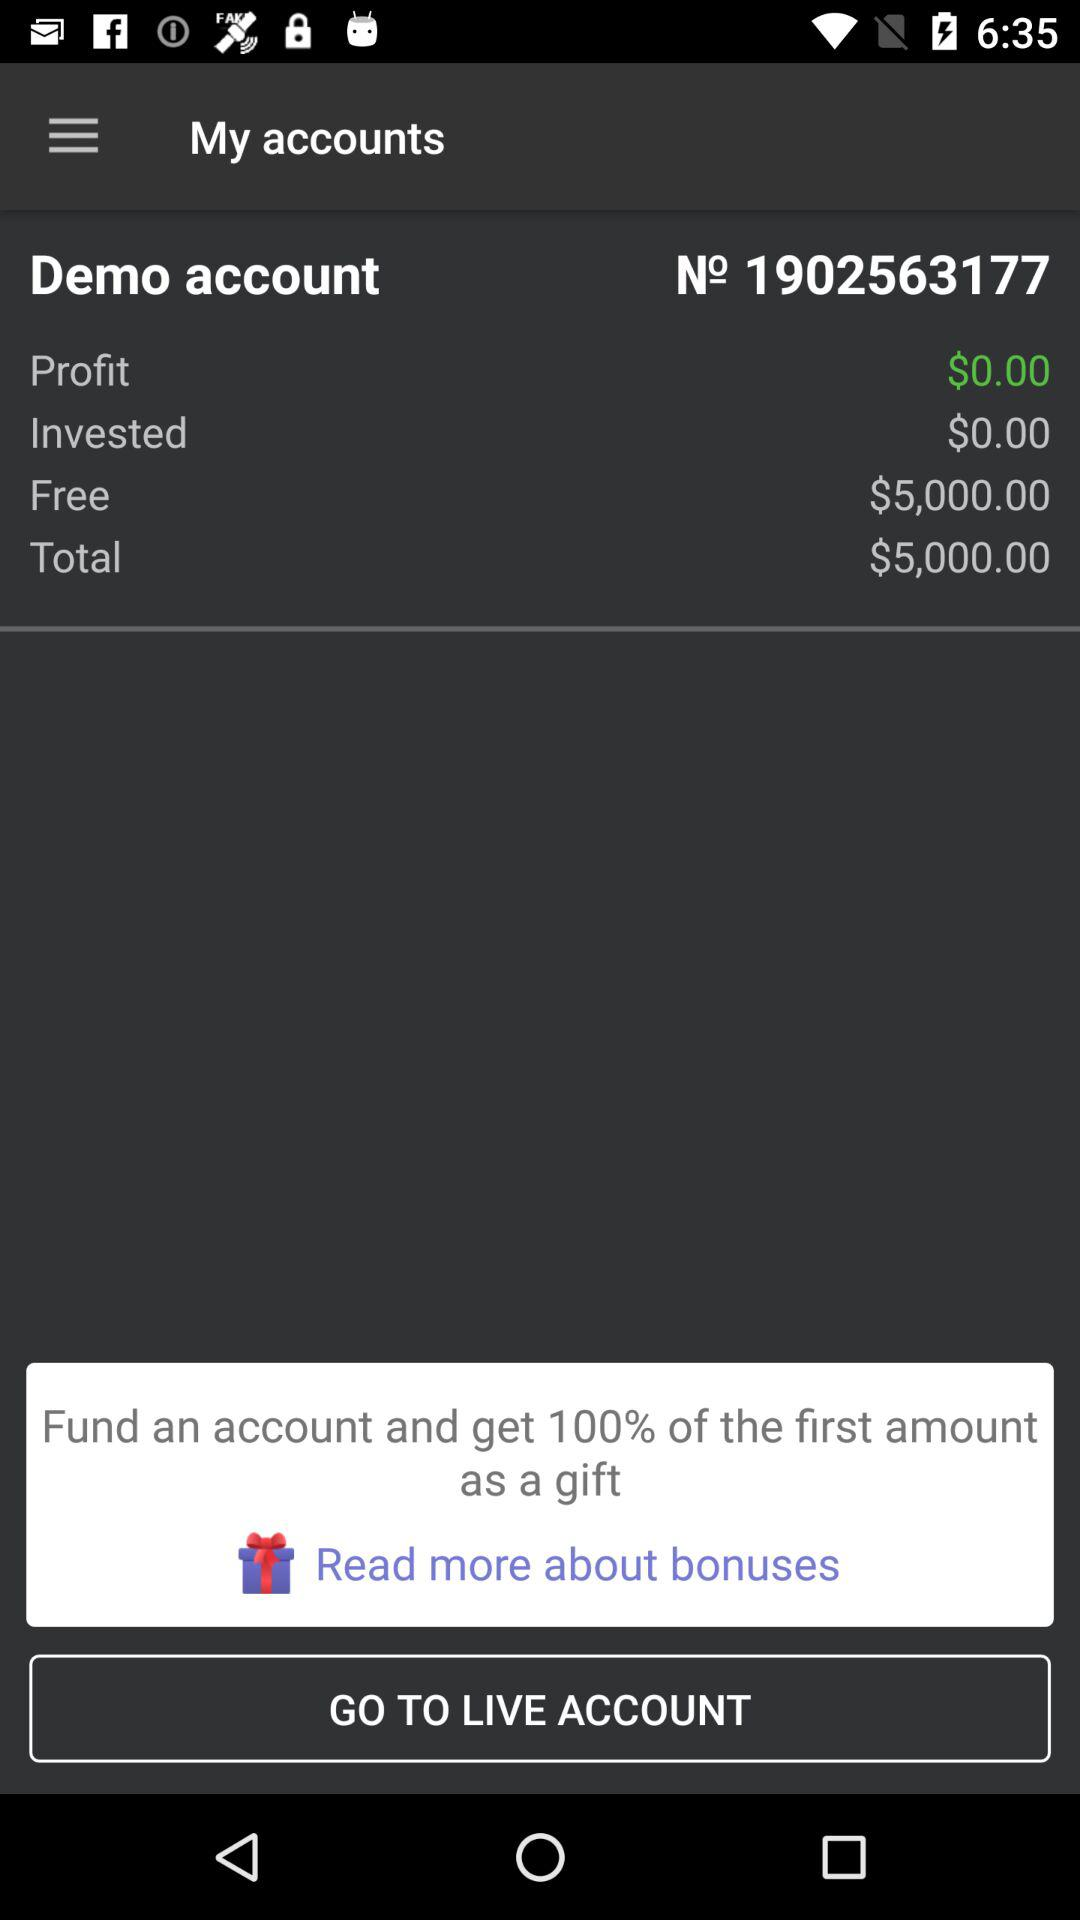What is the profit amount? The profit amount is $0.00. 